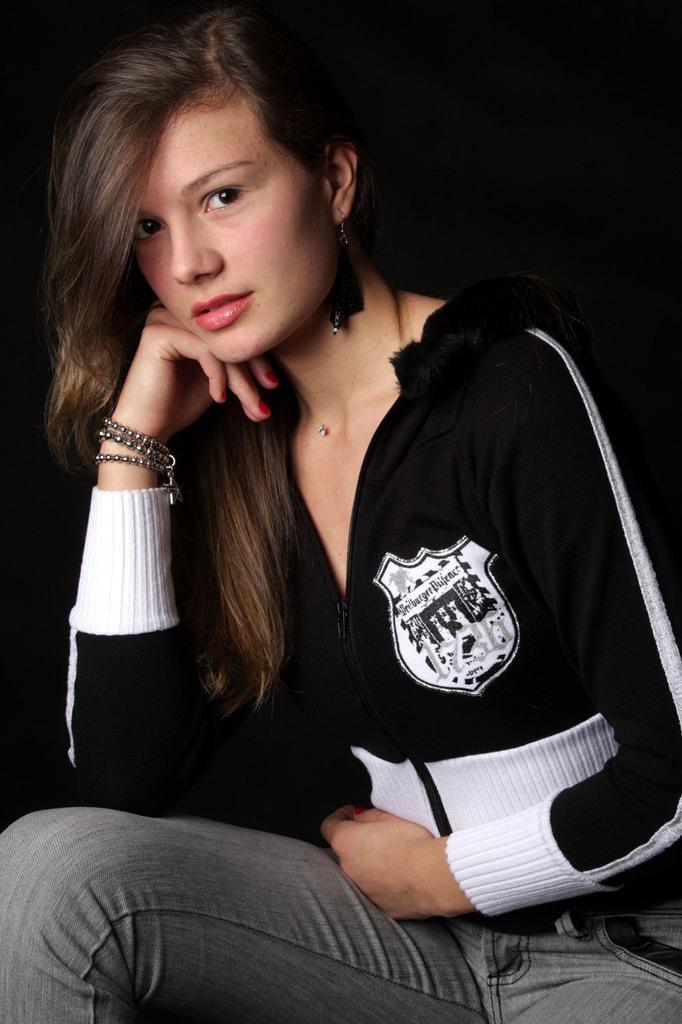Can you describe this image briefly? In the image we can see a woman wearing clothes, bracelet and earring and the backgrounds in dark. 